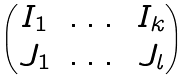<formula> <loc_0><loc_0><loc_500><loc_500>\begin{pmatrix} I _ { 1 } & \dots & I _ { k } \\ J _ { 1 } & \dots & J _ { l } \end{pmatrix}</formula> 